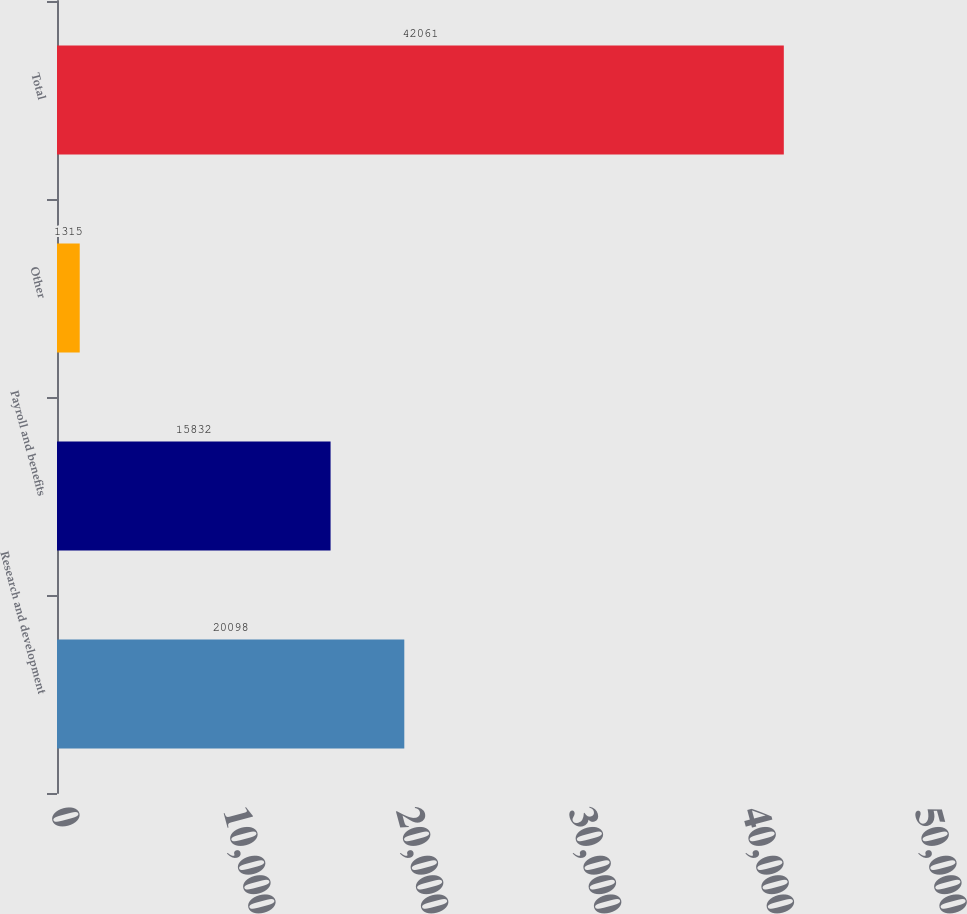Convert chart. <chart><loc_0><loc_0><loc_500><loc_500><bar_chart><fcel>Research and development<fcel>Payroll and benefits<fcel>Other<fcel>Total<nl><fcel>20098<fcel>15832<fcel>1315<fcel>42061<nl></chart> 